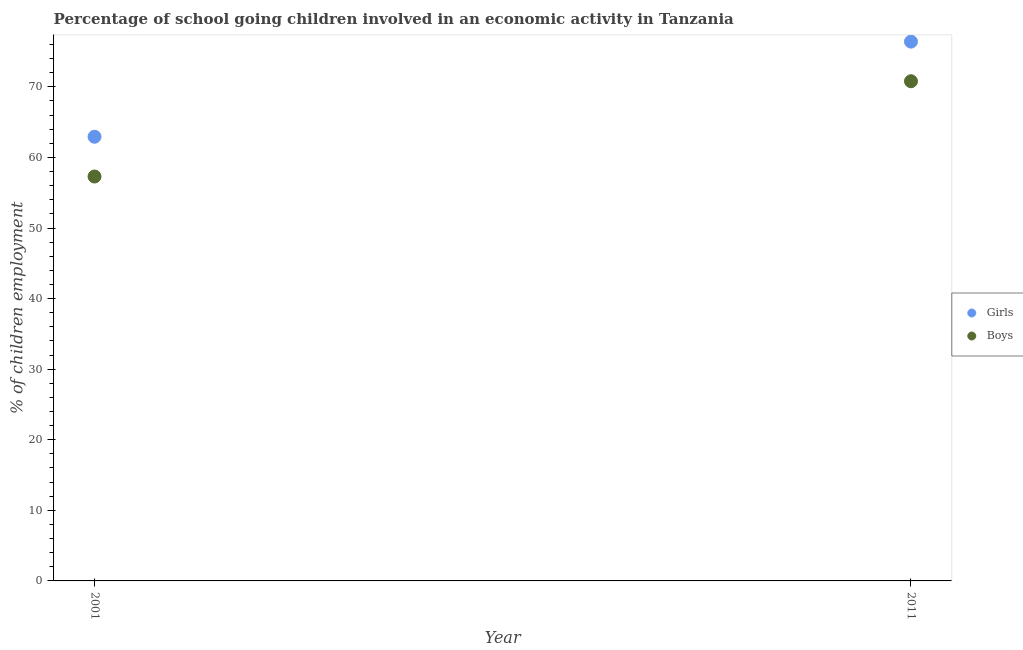How many different coloured dotlines are there?
Make the answer very short. 2. What is the percentage of school going boys in 2001?
Provide a succinct answer. 57.3. Across all years, what is the maximum percentage of school going boys?
Keep it short and to the point. 70.8. Across all years, what is the minimum percentage of school going girls?
Make the answer very short. 62.93. What is the total percentage of school going girls in the graph?
Ensure brevity in your answer.  139.35. What is the difference between the percentage of school going boys in 2001 and that in 2011?
Keep it short and to the point. -13.5. What is the difference between the percentage of school going boys in 2011 and the percentage of school going girls in 2001?
Your response must be concise. 7.87. What is the average percentage of school going girls per year?
Offer a terse response. 69.67. In the year 2001, what is the difference between the percentage of school going girls and percentage of school going boys?
Offer a terse response. 5.63. In how many years, is the percentage of school going boys greater than 8 %?
Provide a succinct answer. 2. What is the ratio of the percentage of school going girls in 2001 to that in 2011?
Your answer should be compact. 0.82. Is the percentage of school going girls strictly greater than the percentage of school going boys over the years?
Offer a terse response. Yes. What is the difference between two consecutive major ticks on the Y-axis?
Your response must be concise. 10. Are the values on the major ticks of Y-axis written in scientific E-notation?
Your response must be concise. No. Does the graph contain any zero values?
Offer a terse response. No. Where does the legend appear in the graph?
Your answer should be compact. Center right. How many legend labels are there?
Provide a short and direct response. 2. How are the legend labels stacked?
Your response must be concise. Vertical. What is the title of the graph?
Give a very brief answer. Percentage of school going children involved in an economic activity in Tanzania. What is the label or title of the X-axis?
Give a very brief answer. Year. What is the label or title of the Y-axis?
Your answer should be compact. % of children employment. What is the % of children employment of Girls in 2001?
Your answer should be compact. 62.93. What is the % of children employment of Boys in 2001?
Your answer should be compact. 57.3. What is the % of children employment of Girls in 2011?
Your response must be concise. 76.41. What is the % of children employment in Boys in 2011?
Your response must be concise. 70.8. Across all years, what is the maximum % of children employment of Girls?
Your response must be concise. 76.41. Across all years, what is the maximum % of children employment in Boys?
Ensure brevity in your answer.  70.8. Across all years, what is the minimum % of children employment in Girls?
Offer a very short reply. 62.93. Across all years, what is the minimum % of children employment of Boys?
Offer a terse response. 57.3. What is the total % of children employment of Girls in the graph?
Offer a terse response. 139.35. What is the total % of children employment of Boys in the graph?
Provide a succinct answer. 128.1. What is the difference between the % of children employment of Girls in 2001 and that in 2011?
Your answer should be compact. -13.48. What is the difference between the % of children employment in Boys in 2001 and that in 2011?
Provide a short and direct response. -13.5. What is the difference between the % of children employment in Girls in 2001 and the % of children employment in Boys in 2011?
Offer a terse response. -7.87. What is the average % of children employment in Girls per year?
Ensure brevity in your answer.  69.67. What is the average % of children employment in Boys per year?
Offer a terse response. 64.05. In the year 2001, what is the difference between the % of children employment in Girls and % of children employment in Boys?
Your answer should be compact. 5.63. In the year 2011, what is the difference between the % of children employment of Girls and % of children employment of Boys?
Provide a short and direct response. 5.61. What is the ratio of the % of children employment in Girls in 2001 to that in 2011?
Your answer should be very brief. 0.82. What is the ratio of the % of children employment in Boys in 2001 to that in 2011?
Make the answer very short. 0.81. What is the difference between the highest and the second highest % of children employment of Girls?
Your answer should be compact. 13.48. What is the difference between the highest and the second highest % of children employment in Boys?
Your answer should be compact. 13.5. What is the difference between the highest and the lowest % of children employment of Girls?
Offer a terse response. 13.48. What is the difference between the highest and the lowest % of children employment of Boys?
Give a very brief answer. 13.5. 